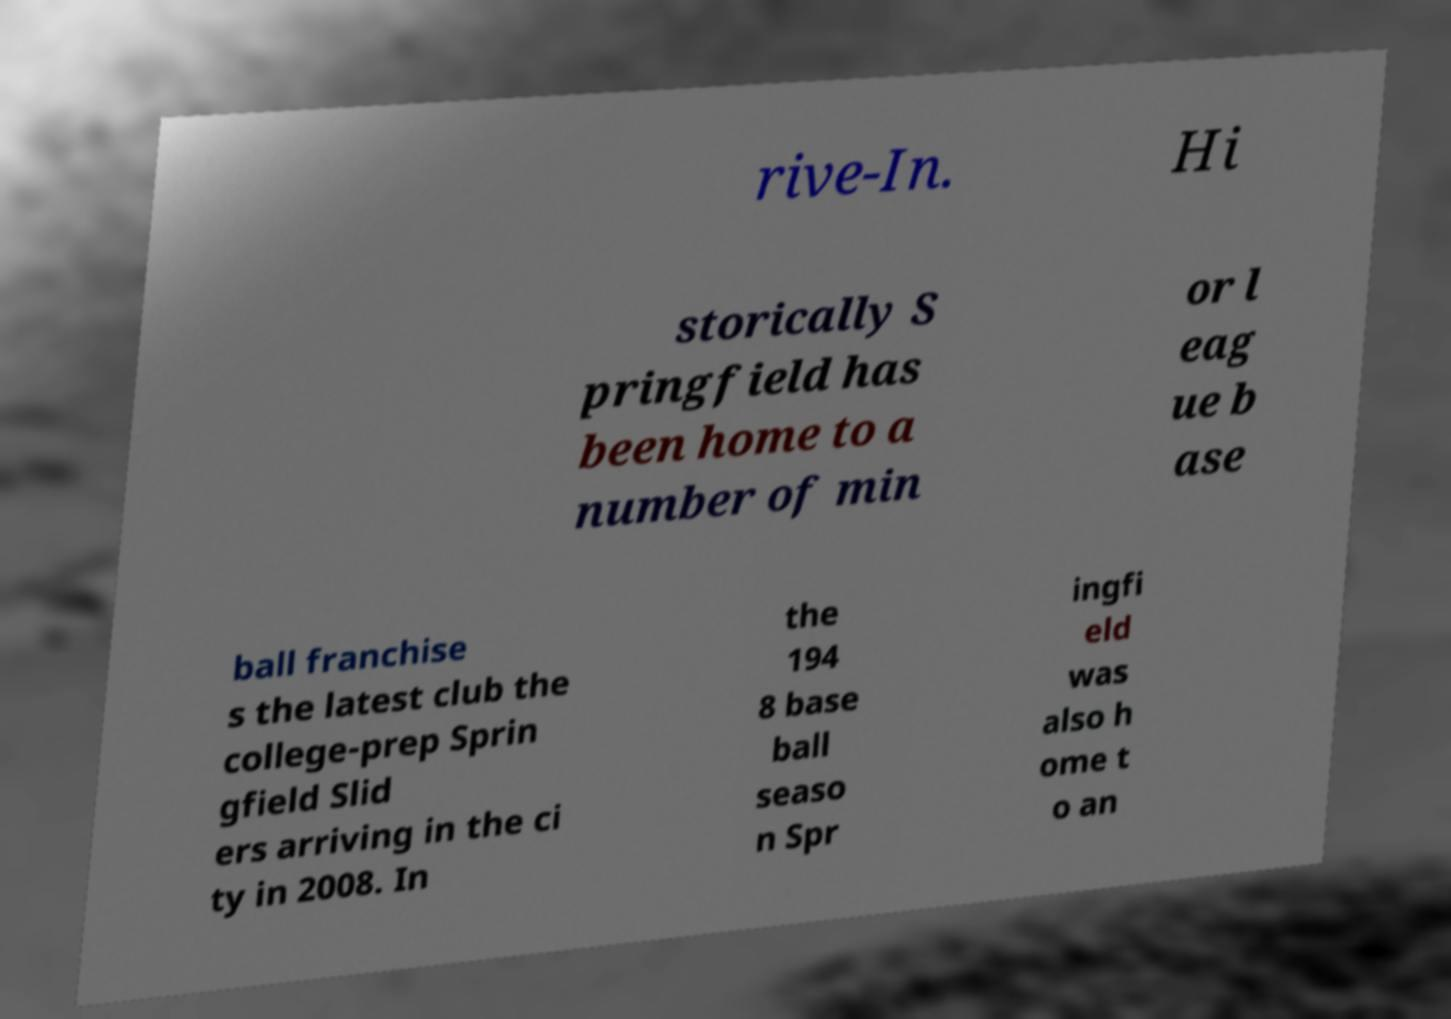What messages or text are displayed in this image? I need them in a readable, typed format. rive-In. Hi storically S pringfield has been home to a number of min or l eag ue b ase ball franchise s the latest club the college-prep Sprin gfield Slid ers arriving in the ci ty in 2008. In the 194 8 base ball seaso n Spr ingfi eld was also h ome t o an 